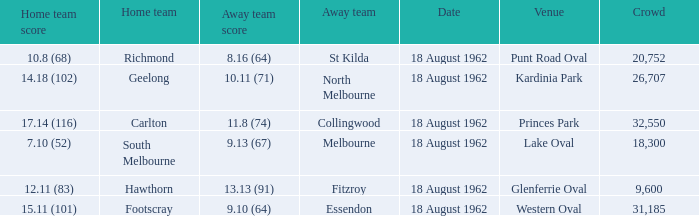What was the home team when the away team scored 9.10 (64)? Footscray. 